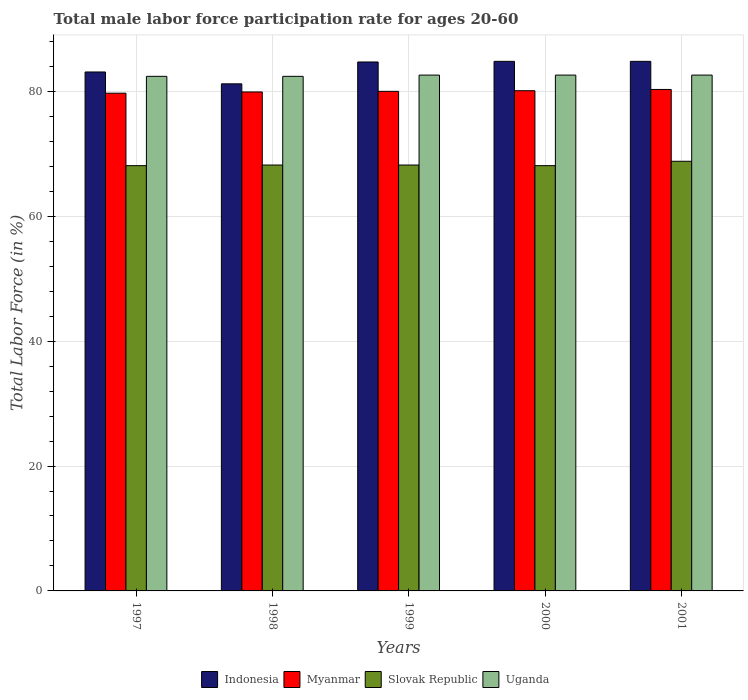How many different coloured bars are there?
Your answer should be very brief. 4. Are the number of bars per tick equal to the number of legend labels?
Keep it short and to the point. Yes. How many bars are there on the 2nd tick from the left?
Ensure brevity in your answer.  4. What is the label of the 3rd group of bars from the left?
Ensure brevity in your answer.  1999. In how many cases, is the number of bars for a given year not equal to the number of legend labels?
Offer a terse response. 0. What is the male labor force participation rate in Myanmar in 1998?
Make the answer very short. 79.9. Across all years, what is the maximum male labor force participation rate in Myanmar?
Provide a succinct answer. 80.3. Across all years, what is the minimum male labor force participation rate in Indonesia?
Your response must be concise. 81.2. In which year was the male labor force participation rate in Slovak Republic maximum?
Ensure brevity in your answer.  2001. What is the total male labor force participation rate in Slovak Republic in the graph?
Give a very brief answer. 341.4. What is the difference between the male labor force participation rate in Myanmar in 1998 and that in 2000?
Your answer should be very brief. -0.2. What is the difference between the male labor force participation rate in Slovak Republic in 2000 and the male labor force participation rate in Uganda in 1998?
Your response must be concise. -14.3. What is the average male labor force participation rate in Myanmar per year?
Ensure brevity in your answer.  80. In the year 2001, what is the difference between the male labor force participation rate in Slovak Republic and male labor force participation rate in Uganda?
Your answer should be very brief. -13.8. In how many years, is the male labor force participation rate in Myanmar greater than 68 %?
Offer a very short reply. 5. What is the ratio of the male labor force participation rate in Indonesia in 1997 to that in 2001?
Give a very brief answer. 0.98. Is the male labor force participation rate in Slovak Republic in 1997 less than that in 1998?
Your answer should be compact. Yes. Is the difference between the male labor force participation rate in Slovak Republic in 1998 and 1999 greater than the difference between the male labor force participation rate in Uganda in 1998 and 1999?
Provide a short and direct response. Yes. What is the difference between the highest and the second highest male labor force participation rate in Slovak Republic?
Your response must be concise. 0.6. What is the difference between the highest and the lowest male labor force participation rate in Myanmar?
Your answer should be compact. 0.6. In how many years, is the male labor force participation rate in Indonesia greater than the average male labor force participation rate in Indonesia taken over all years?
Make the answer very short. 3. Is the sum of the male labor force participation rate in Myanmar in 1997 and 2001 greater than the maximum male labor force participation rate in Indonesia across all years?
Provide a short and direct response. Yes. What does the 2nd bar from the left in 1998 represents?
Give a very brief answer. Myanmar. What does the 3rd bar from the right in 1998 represents?
Your answer should be very brief. Myanmar. How many bars are there?
Give a very brief answer. 20. What is the difference between two consecutive major ticks on the Y-axis?
Your response must be concise. 20. Does the graph contain any zero values?
Ensure brevity in your answer.  No. What is the title of the graph?
Ensure brevity in your answer.  Total male labor force participation rate for ages 20-60. What is the Total Labor Force (in %) in Indonesia in 1997?
Provide a short and direct response. 83.1. What is the Total Labor Force (in %) of Myanmar in 1997?
Your answer should be compact. 79.7. What is the Total Labor Force (in %) of Slovak Republic in 1997?
Provide a succinct answer. 68.1. What is the Total Labor Force (in %) of Uganda in 1997?
Provide a short and direct response. 82.4. What is the Total Labor Force (in %) of Indonesia in 1998?
Your response must be concise. 81.2. What is the Total Labor Force (in %) in Myanmar in 1998?
Provide a succinct answer. 79.9. What is the Total Labor Force (in %) of Slovak Republic in 1998?
Give a very brief answer. 68.2. What is the Total Labor Force (in %) of Uganda in 1998?
Provide a short and direct response. 82.4. What is the Total Labor Force (in %) in Indonesia in 1999?
Provide a succinct answer. 84.7. What is the Total Labor Force (in %) of Myanmar in 1999?
Your answer should be very brief. 80. What is the Total Labor Force (in %) in Slovak Republic in 1999?
Provide a short and direct response. 68.2. What is the Total Labor Force (in %) in Uganda in 1999?
Your answer should be very brief. 82.6. What is the Total Labor Force (in %) of Indonesia in 2000?
Provide a short and direct response. 84.8. What is the Total Labor Force (in %) of Myanmar in 2000?
Your answer should be compact. 80.1. What is the Total Labor Force (in %) in Slovak Republic in 2000?
Your response must be concise. 68.1. What is the Total Labor Force (in %) of Uganda in 2000?
Offer a very short reply. 82.6. What is the Total Labor Force (in %) in Indonesia in 2001?
Make the answer very short. 84.8. What is the Total Labor Force (in %) of Myanmar in 2001?
Keep it short and to the point. 80.3. What is the Total Labor Force (in %) in Slovak Republic in 2001?
Provide a short and direct response. 68.8. What is the Total Labor Force (in %) in Uganda in 2001?
Keep it short and to the point. 82.6. Across all years, what is the maximum Total Labor Force (in %) of Indonesia?
Offer a very short reply. 84.8. Across all years, what is the maximum Total Labor Force (in %) of Myanmar?
Your answer should be compact. 80.3. Across all years, what is the maximum Total Labor Force (in %) in Slovak Republic?
Provide a succinct answer. 68.8. Across all years, what is the maximum Total Labor Force (in %) of Uganda?
Give a very brief answer. 82.6. Across all years, what is the minimum Total Labor Force (in %) in Indonesia?
Ensure brevity in your answer.  81.2. Across all years, what is the minimum Total Labor Force (in %) of Myanmar?
Keep it short and to the point. 79.7. Across all years, what is the minimum Total Labor Force (in %) in Slovak Republic?
Provide a short and direct response. 68.1. Across all years, what is the minimum Total Labor Force (in %) of Uganda?
Ensure brevity in your answer.  82.4. What is the total Total Labor Force (in %) in Indonesia in the graph?
Offer a terse response. 418.6. What is the total Total Labor Force (in %) in Myanmar in the graph?
Provide a succinct answer. 400. What is the total Total Labor Force (in %) in Slovak Republic in the graph?
Provide a succinct answer. 341.4. What is the total Total Labor Force (in %) in Uganda in the graph?
Give a very brief answer. 412.6. What is the difference between the Total Labor Force (in %) in Indonesia in 1997 and that in 1998?
Make the answer very short. 1.9. What is the difference between the Total Labor Force (in %) of Myanmar in 1997 and that in 1998?
Provide a succinct answer. -0.2. What is the difference between the Total Labor Force (in %) of Slovak Republic in 1997 and that in 1998?
Provide a short and direct response. -0.1. What is the difference between the Total Labor Force (in %) of Uganda in 1997 and that in 1998?
Provide a short and direct response. 0. What is the difference between the Total Labor Force (in %) of Myanmar in 1997 and that in 1999?
Offer a terse response. -0.3. What is the difference between the Total Labor Force (in %) of Slovak Republic in 1997 and that in 1999?
Ensure brevity in your answer.  -0.1. What is the difference between the Total Labor Force (in %) of Uganda in 1997 and that in 1999?
Your answer should be compact. -0.2. What is the difference between the Total Labor Force (in %) of Indonesia in 1997 and that in 2000?
Ensure brevity in your answer.  -1.7. What is the difference between the Total Labor Force (in %) of Slovak Republic in 1997 and that in 2000?
Your answer should be compact. 0. What is the difference between the Total Labor Force (in %) of Indonesia in 1998 and that in 1999?
Offer a very short reply. -3.5. What is the difference between the Total Labor Force (in %) in Slovak Republic in 1998 and that in 1999?
Your answer should be compact. 0. What is the difference between the Total Labor Force (in %) of Slovak Republic in 1998 and that in 2000?
Offer a very short reply. 0.1. What is the difference between the Total Labor Force (in %) of Indonesia in 1998 and that in 2001?
Offer a very short reply. -3.6. What is the difference between the Total Labor Force (in %) of Myanmar in 1998 and that in 2001?
Your answer should be compact. -0.4. What is the difference between the Total Labor Force (in %) of Slovak Republic in 1998 and that in 2001?
Offer a terse response. -0.6. What is the difference between the Total Labor Force (in %) in Myanmar in 1999 and that in 2000?
Your answer should be very brief. -0.1. What is the difference between the Total Labor Force (in %) of Slovak Republic in 1999 and that in 2001?
Your answer should be very brief. -0.6. What is the difference between the Total Labor Force (in %) of Indonesia in 2000 and that in 2001?
Keep it short and to the point. 0. What is the difference between the Total Labor Force (in %) in Uganda in 2000 and that in 2001?
Provide a succinct answer. 0. What is the difference between the Total Labor Force (in %) of Indonesia in 1997 and the Total Labor Force (in %) of Myanmar in 1998?
Keep it short and to the point. 3.2. What is the difference between the Total Labor Force (in %) of Indonesia in 1997 and the Total Labor Force (in %) of Uganda in 1998?
Provide a short and direct response. 0.7. What is the difference between the Total Labor Force (in %) in Myanmar in 1997 and the Total Labor Force (in %) in Slovak Republic in 1998?
Keep it short and to the point. 11.5. What is the difference between the Total Labor Force (in %) of Myanmar in 1997 and the Total Labor Force (in %) of Uganda in 1998?
Give a very brief answer. -2.7. What is the difference between the Total Labor Force (in %) of Slovak Republic in 1997 and the Total Labor Force (in %) of Uganda in 1998?
Offer a very short reply. -14.3. What is the difference between the Total Labor Force (in %) of Indonesia in 1997 and the Total Labor Force (in %) of Slovak Republic in 1999?
Your answer should be very brief. 14.9. What is the difference between the Total Labor Force (in %) in Indonesia in 1997 and the Total Labor Force (in %) in Uganda in 1999?
Give a very brief answer. 0.5. What is the difference between the Total Labor Force (in %) in Myanmar in 1997 and the Total Labor Force (in %) in Slovak Republic in 1999?
Keep it short and to the point. 11.5. What is the difference between the Total Labor Force (in %) of Slovak Republic in 1997 and the Total Labor Force (in %) of Uganda in 1999?
Keep it short and to the point. -14.5. What is the difference between the Total Labor Force (in %) in Myanmar in 1997 and the Total Labor Force (in %) in Slovak Republic in 2000?
Your answer should be compact. 11.6. What is the difference between the Total Labor Force (in %) of Indonesia in 1997 and the Total Labor Force (in %) of Slovak Republic in 2001?
Your answer should be compact. 14.3. What is the difference between the Total Labor Force (in %) in Indonesia in 1997 and the Total Labor Force (in %) in Uganda in 2001?
Provide a succinct answer. 0.5. What is the difference between the Total Labor Force (in %) in Indonesia in 1998 and the Total Labor Force (in %) in Slovak Republic in 1999?
Make the answer very short. 13. What is the difference between the Total Labor Force (in %) of Myanmar in 1998 and the Total Labor Force (in %) of Uganda in 1999?
Offer a very short reply. -2.7. What is the difference between the Total Labor Force (in %) of Slovak Republic in 1998 and the Total Labor Force (in %) of Uganda in 1999?
Offer a very short reply. -14.4. What is the difference between the Total Labor Force (in %) in Indonesia in 1998 and the Total Labor Force (in %) in Myanmar in 2000?
Provide a succinct answer. 1.1. What is the difference between the Total Labor Force (in %) of Indonesia in 1998 and the Total Labor Force (in %) of Slovak Republic in 2000?
Make the answer very short. 13.1. What is the difference between the Total Labor Force (in %) of Myanmar in 1998 and the Total Labor Force (in %) of Slovak Republic in 2000?
Make the answer very short. 11.8. What is the difference between the Total Labor Force (in %) of Slovak Republic in 1998 and the Total Labor Force (in %) of Uganda in 2000?
Keep it short and to the point. -14.4. What is the difference between the Total Labor Force (in %) in Myanmar in 1998 and the Total Labor Force (in %) in Uganda in 2001?
Your answer should be very brief. -2.7. What is the difference between the Total Labor Force (in %) in Slovak Republic in 1998 and the Total Labor Force (in %) in Uganda in 2001?
Keep it short and to the point. -14.4. What is the difference between the Total Labor Force (in %) of Indonesia in 1999 and the Total Labor Force (in %) of Myanmar in 2000?
Offer a terse response. 4.6. What is the difference between the Total Labor Force (in %) in Slovak Republic in 1999 and the Total Labor Force (in %) in Uganda in 2000?
Your answer should be very brief. -14.4. What is the difference between the Total Labor Force (in %) in Indonesia in 1999 and the Total Labor Force (in %) in Myanmar in 2001?
Offer a terse response. 4.4. What is the difference between the Total Labor Force (in %) of Indonesia in 1999 and the Total Labor Force (in %) of Slovak Republic in 2001?
Offer a terse response. 15.9. What is the difference between the Total Labor Force (in %) in Indonesia in 1999 and the Total Labor Force (in %) in Uganda in 2001?
Offer a terse response. 2.1. What is the difference between the Total Labor Force (in %) in Myanmar in 1999 and the Total Labor Force (in %) in Slovak Republic in 2001?
Provide a short and direct response. 11.2. What is the difference between the Total Labor Force (in %) of Slovak Republic in 1999 and the Total Labor Force (in %) of Uganda in 2001?
Offer a terse response. -14.4. What is the difference between the Total Labor Force (in %) in Indonesia in 2000 and the Total Labor Force (in %) in Myanmar in 2001?
Keep it short and to the point. 4.5. What is the difference between the Total Labor Force (in %) in Indonesia in 2000 and the Total Labor Force (in %) in Slovak Republic in 2001?
Make the answer very short. 16. What is the difference between the Total Labor Force (in %) of Indonesia in 2000 and the Total Labor Force (in %) of Uganda in 2001?
Provide a succinct answer. 2.2. What is the difference between the Total Labor Force (in %) in Myanmar in 2000 and the Total Labor Force (in %) in Uganda in 2001?
Offer a very short reply. -2.5. What is the average Total Labor Force (in %) in Indonesia per year?
Give a very brief answer. 83.72. What is the average Total Labor Force (in %) in Myanmar per year?
Offer a terse response. 80. What is the average Total Labor Force (in %) of Slovak Republic per year?
Your response must be concise. 68.28. What is the average Total Labor Force (in %) in Uganda per year?
Your response must be concise. 82.52. In the year 1997, what is the difference between the Total Labor Force (in %) of Indonesia and Total Labor Force (in %) of Myanmar?
Ensure brevity in your answer.  3.4. In the year 1997, what is the difference between the Total Labor Force (in %) in Indonesia and Total Labor Force (in %) in Slovak Republic?
Your answer should be very brief. 15. In the year 1997, what is the difference between the Total Labor Force (in %) of Indonesia and Total Labor Force (in %) of Uganda?
Ensure brevity in your answer.  0.7. In the year 1997, what is the difference between the Total Labor Force (in %) in Myanmar and Total Labor Force (in %) in Slovak Republic?
Offer a very short reply. 11.6. In the year 1997, what is the difference between the Total Labor Force (in %) in Myanmar and Total Labor Force (in %) in Uganda?
Your response must be concise. -2.7. In the year 1997, what is the difference between the Total Labor Force (in %) of Slovak Republic and Total Labor Force (in %) of Uganda?
Ensure brevity in your answer.  -14.3. In the year 1998, what is the difference between the Total Labor Force (in %) in Indonesia and Total Labor Force (in %) in Slovak Republic?
Your answer should be compact. 13. In the year 1998, what is the difference between the Total Labor Force (in %) in Indonesia and Total Labor Force (in %) in Uganda?
Make the answer very short. -1.2. In the year 1998, what is the difference between the Total Labor Force (in %) in Myanmar and Total Labor Force (in %) in Uganda?
Keep it short and to the point. -2.5. In the year 1998, what is the difference between the Total Labor Force (in %) of Slovak Republic and Total Labor Force (in %) of Uganda?
Your answer should be very brief. -14.2. In the year 1999, what is the difference between the Total Labor Force (in %) of Indonesia and Total Labor Force (in %) of Slovak Republic?
Offer a very short reply. 16.5. In the year 1999, what is the difference between the Total Labor Force (in %) of Indonesia and Total Labor Force (in %) of Uganda?
Provide a succinct answer. 2.1. In the year 1999, what is the difference between the Total Labor Force (in %) in Slovak Republic and Total Labor Force (in %) in Uganda?
Make the answer very short. -14.4. In the year 2000, what is the difference between the Total Labor Force (in %) of Indonesia and Total Labor Force (in %) of Myanmar?
Offer a very short reply. 4.7. In the year 2000, what is the difference between the Total Labor Force (in %) in Indonesia and Total Labor Force (in %) in Slovak Republic?
Make the answer very short. 16.7. In the year 2000, what is the difference between the Total Labor Force (in %) in Indonesia and Total Labor Force (in %) in Uganda?
Provide a short and direct response. 2.2. In the year 2000, what is the difference between the Total Labor Force (in %) of Myanmar and Total Labor Force (in %) of Uganda?
Your answer should be compact. -2.5. In the year 2001, what is the difference between the Total Labor Force (in %) in Indonesia and Total Labor Force (in %) in Slovak Republic?
Make the answer very short. 16. In the year 2001, what is the difference between the Total Labor Force (in %) of Myanmar and Total Labor Force (in %) of Slovak Republic?
Provide a short and direct response. 11.5. In the year 2001, what is the difference between the Total Labor Force (in %) of Myanmar and Total Labor Force (in %) of Uganda?
Ensure brevity in your answer.  -2.3. What is the ratio of the Total Labor Force (in %) in Indonesia in 1997 to that in 1998?
Your answer should be very brief. 1.02. What is the ratio of the Total Labor Force (in %) in Uganda in 1997 to that in 1998?
Your response must be concise. 1. What is the ratio of the Total Labor Force (in %) of Indonesia in 1997 to that in 1999?
Provide a succinct answer. 0.98. What is the ratio of the Total Labor Force (in %) of Myanmar in 1997 to that in 1999?
Your answer should be very brief. 1. What is the ratio of the Total Labor Force (in %) in Slovak Republic in 1997 to that in 1999?
Ensure brevity in your answer.  1. What is the ratio of the Total Labor Force (in %) of Myanmar in 1997 to that in 2001?
Provide a short and direct response. 0.99. What is the ratio of the Total Labor Force (in %) in Indonesia in 1998 to that in 1999?
Keep it short and to the point. 0.96. What is the ratio of the Total Labor Force (in %) in Uganda in 1998 to that in 1999?
Provide a succinct answer. 1. What is the ratio of the Total Labor Force (in %) of Indonesia in 1998 to that in 2000?
Offer a very short reply. 0.96. What is the ratio of the Total Labor Force (in %) of Myanmar in 1998 to that in 2000?
Ensure brevity in your answer.  1. What is the ratio of the Total Labor Force (in %) of Slovak Republic in 1998 to that in 2000?
Your answer should be compact. 1. What is the ratio of the Total Labor Force (in %) of Uganda in 1998 to that in 2000?
Your answer should be compact. 1. What is the ratio of the Total Labor Force (in %) in Indonesia in 1998 to that in 2001?
Offer a very short reply. 0.96. What is the ratio of the Total Labor Force (in %) in Myanmar in 1998 to that in 2001?
Provide a succinct answer. 0.99. What is the ratio of the Total Labor Force (in %) of Slovak Republic in 1998 to that in 2001?
Offer a very short reply. 0.99. What is the ratio of the Total Labor Force (in %) in Uganda in 1998 to that in 2001?
Offer a very short reply. 1. What is the ratio of the Total Labor Force (in %) of Myanmar in 1999 to that in 2000?
Your response must be concise. 1. What is the ratio of the Total Labor Force (in %) in Slovak Republic in 1999 to that in 2000?
Your answer should be compact. 1. What is the ratio of the Total Labor Force (in %) of Indonesia in 1999 to that in 2001?
Ensure brevity in your answer.  1. What is the ratio of the Total Labor Force (in %) in Myanmar in 1999 to that in 2001?
Keep it short and to the point. 1. What is the ratio of the Total Labor Force (in %) in Uganda in 1999 to that in 2001?
Offer a very short reply. 1. What is the ratio of the Total Labor Force (in %) of Indonesia in 2000 to that in 2001?
Offer a very short reply. 1. What is the ratio of the Total Labor Force (in %) in Myanmar in 2000 to that in 2001?
Your response must be concise. 1. What is the ratio of the Total Labor Force (in %) of Slovak Republic in 2000 to that in 2001?
Your answer should be very brief. 0.99. What is the difference between the highest and the second highest Total Labor Force (in %) in Indonesia?
Give a very brief answer. 0. What is the difference between the highest and the second highest Total Labor Force (in %) of Slovak Republic?
Provide a succinct answer. 0.6. What is the difference between the highest and the lowest Total Labor Force (in %) in Indonesia?
Your answer should be compact. 3.6. What is the difference between the highest and the lowest Total Labor Force (in %) in Myanmar?
Your answer should be very brief. 0.6. 